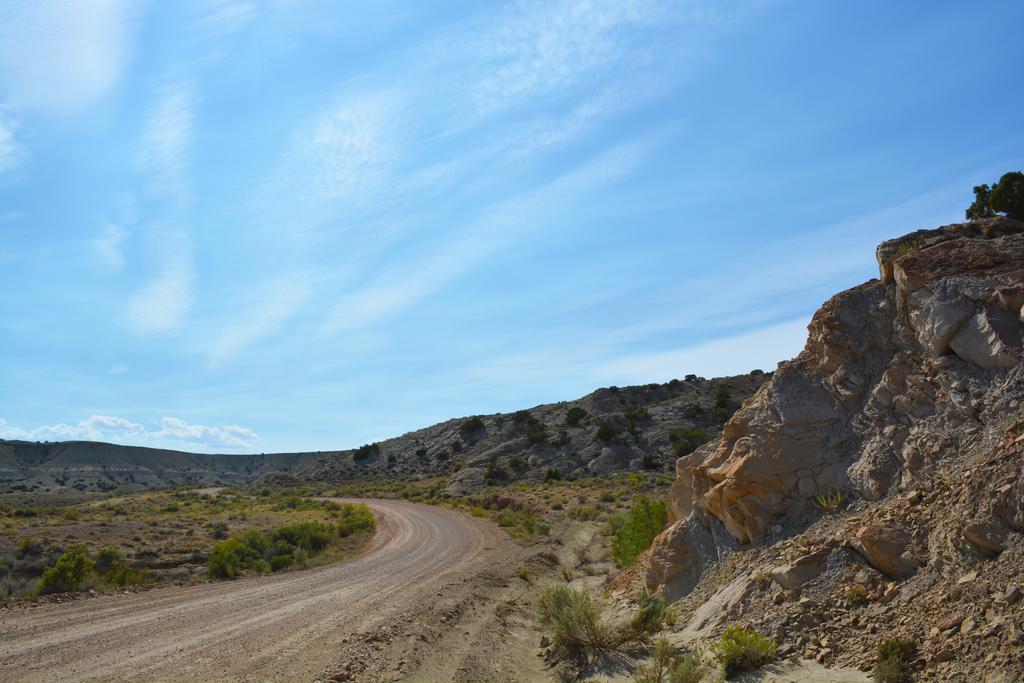Describe this image in one or two sentences. In this picture we can see a road. On the right we can see stones. On the left we can see grass and plants. On the background we can see trees and mountains. On the to we can see sky and clouds. 